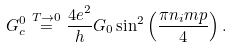<formula> <loc_0><loc_0><loc_500><loc_500>G _ { c } ^ { 0 } \overset { T \to 0 } = \frac { 4 e ^ { 2 } } { h } G _ { 0 } \sin ^ { 2 } \left ( \frac { \pi n _ { i } m p } { 4 } \right ) .</formula> 